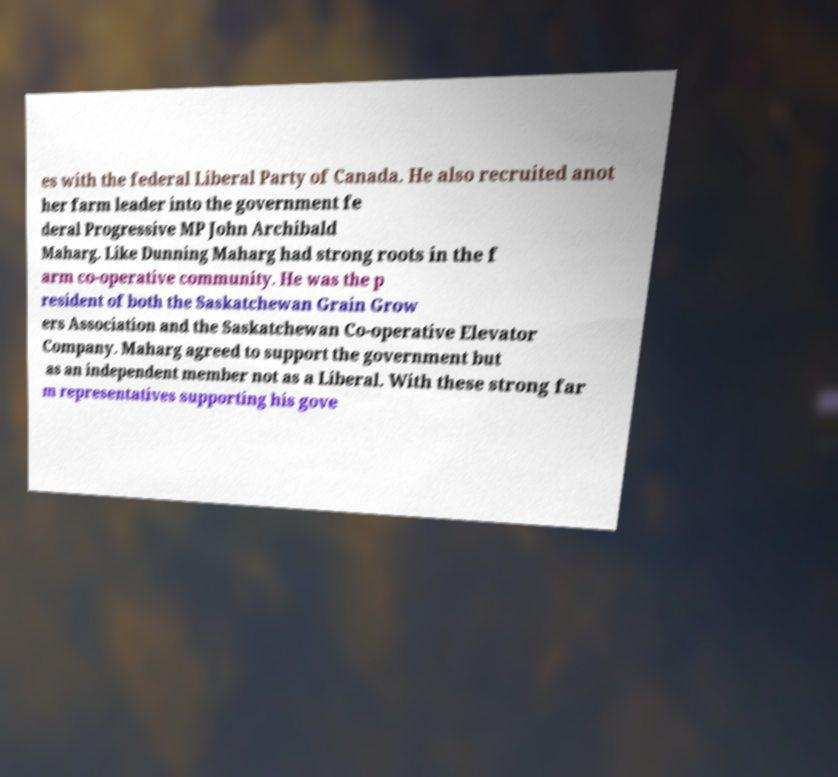Can you read and provide the text displayed in the image?This photo seems to have some interesting text. Can you extract and type it out for me? es with the federal Liberal Party of Canada. He also recruited anot her farm leader into the government fe deral Progressive MP John Archibald Maharg. Like Dunning Maharg had strong roots in the f arm co-operative community. He was the p resident of both the Saskatchewan Grain Grow ers Association and the Saskatchewan Co-operative Elevator Company. Maharg agreed to support the government but as an independent member not as a Liberal. With these strong far m representatives supporting his gove 